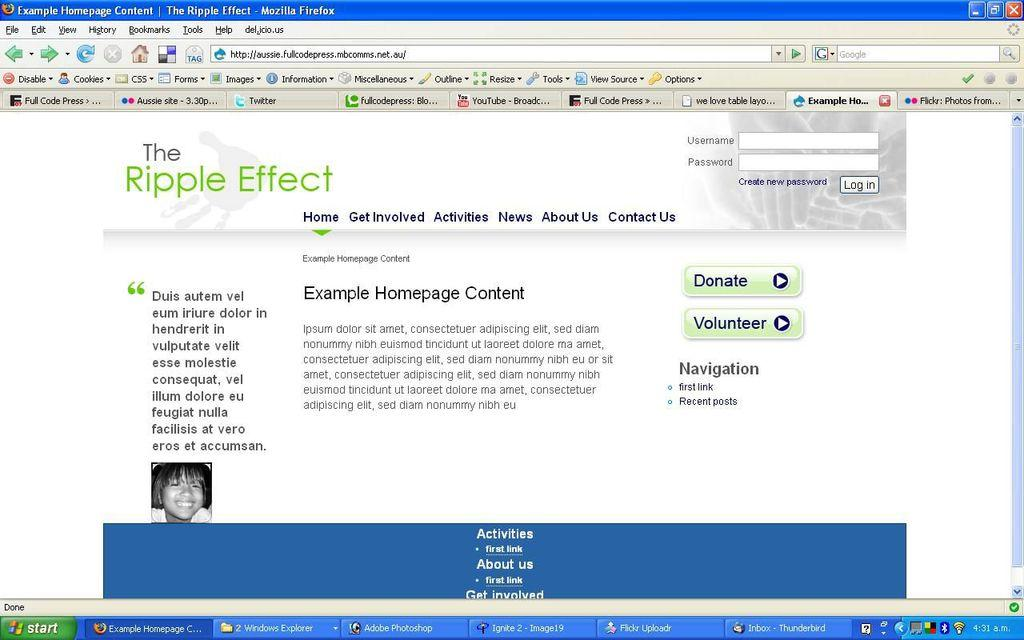Provide a one-sentence caption for the provided image. A windows XP screen with firefox open to example homepage content. 